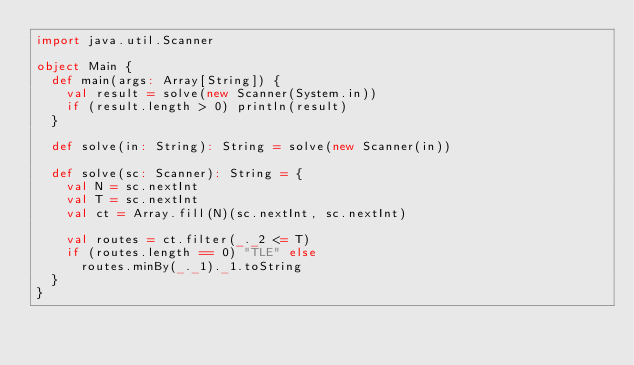Convert code to text. <code><loc_0><loc_0><loc_500><loc_500><_Scala_>import java.util.Scanner

object Main {
  def main(args: Array[String]) {
    val result = solve(new Scanner(System.in))
    if (result.length > 0) println(result)
  }

  def solve(in: String): String = solve(new Scanner(in))

  def solve(sc: Scanner): String = {
    val N = sc.nextInt
    val T = sc.nextInt
    val ct = Array.fill(N)(sc.nextInt, sc.nextInt)

    val routes = ct.filter(_._2 <= T)
    if (routes.length == 0) "TLE" else
      routes.minBy(_._1)._1.toString
  }
}
</code> 